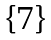Convert formula to latex. <formula><loc_0><loc_0><loc_500><loc_500>\text {  }</formula> 